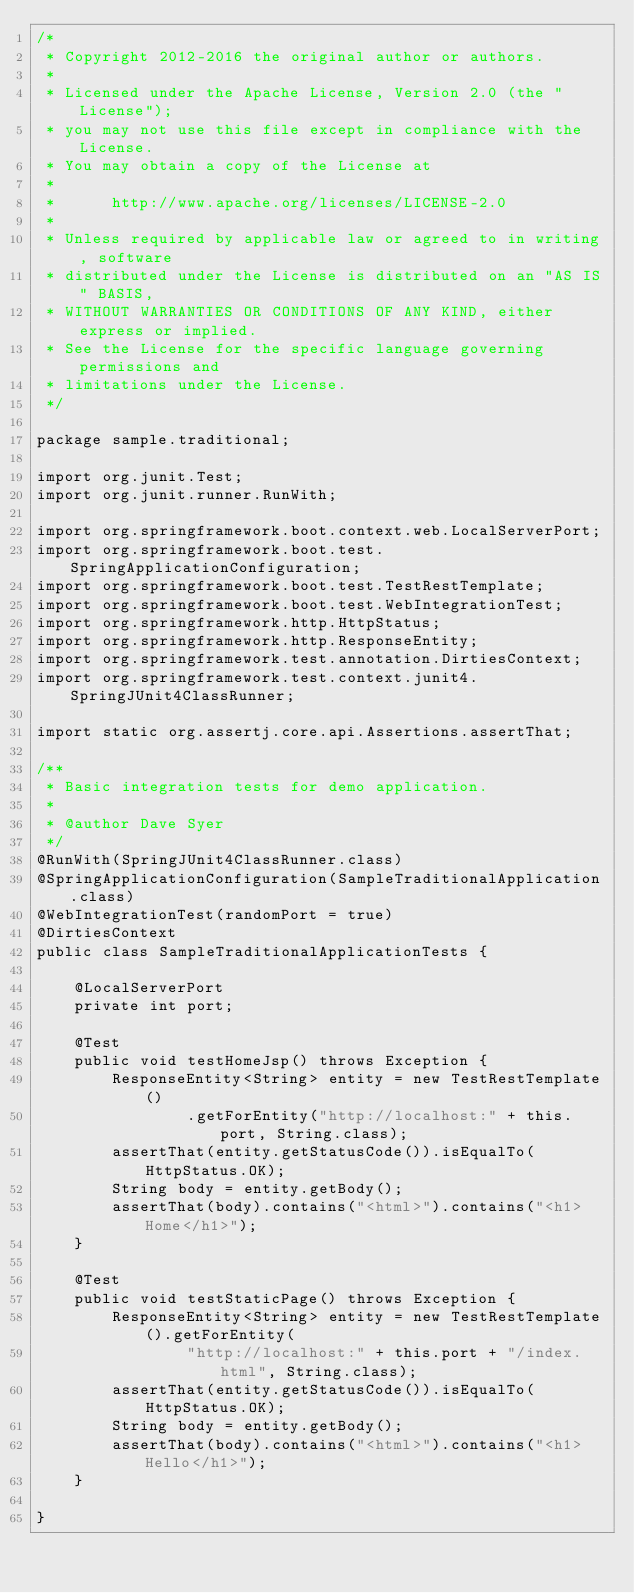Convert code to text. <code><loc_0><loc_0><loc_500><loc_500><_Java_>/*
 * Copyright 2012-2016 the original author or authors.
 *
 * Licensed under the Apache License, Version 2.0 (the "License");
 * you may not use this file except in compliance with the License.
 * You may obtain a copy of the License at
 *
 *      http://www.apache.org/licenses/LICENSE-2.0
 *
 * Unless required by applicable law or agreed to in writing, software
 * distributed under the License is distributed on an "AS IS" BASIS,
 * WITHOUT WARRANTIES OR CONDITIONS OF ANY KIND, either express or implied.
 * See the License for the specific language governing permissions and
 * limitations under the License.
 */

package sample.traditional;

import org.junit.Test;
import org.junit.runner.RunWith;

import org.springframework.boot.context.web.LocalServerPort;
import org.springframework.boot.test.SpringApplicationConfiguration;
import org.springframework.boot.test.TestRestTemplate;
import org.springframework.boot.test.WebIntegrationTest;
import org.springframework.http.HttpStatus;
import org.springframework.http.ResponseEntity;
import org.springframework.test.annotation.DirtiesContext;
import org.springframework.test.context.junit4.SpringJUnit4ClassRunner;

import static org.assertj.core.api.Assertions.assertThat;

/**
 * Basic integration tests for demo application.
 *
 * @author Dave Syer
 */
@RunWith(SpringJUnit4ClassRunner.class)
@SpringApplicationConfiguration(SampleTraditionalApplication.class)
@WebIntegrationTest(randomPort = true)
@DirtiesContext
public class SampleTraditionalApplicationTests {

	@LocalServerPort
	private int port;

	@Test
	public void testHomeJsp() throws Exception {
		ResponseEntity<String> entity = new TestRestTemplate()
				.getForEntity("http://localhost:" + this.port, String.class);
		assertThat(entity.getStatusCode()).isEqualTo(HttpStatus.OK);
		String body = entity.getBody();
		assertThat(body).contains("<html>").contains("<h1>Home</h1>");
	}

	@Test
	public void testStaticPage() throws Exception {
		ResponseEntity<String> entity = new TestRestTemplate().getForEntity(
				"http://localhost:" + this.port + "/index.html", String.class);
		assertThat(entity.getStatusCode()).isEqualTo(HttpStatus.OK);
		String body = entity.getBody();
		assertThat(body).contains("<html>").contains("<h1>Hello</h1>");
	}

}
</code> 